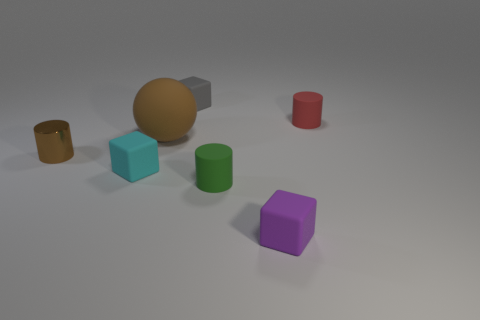What can you say about the arrangement of these objects? The objects are placed in a somewhat scattered arrangement, yet there's a sense of balance in the composition. Some objects, like the cylinders and the cube, are aligned with each other which may suggest deliberate placement for visual appeal or part of a set task within a controlled environment.  Could there be a reason why these particular objects were chosen? These objects might have been chosen for their distinct shapes and colors, typically used in visual experiments or to test computer vision algorithms. Their simple geometric forms are perfect for recognition tasks or to study how light interacts with different surfaces. 